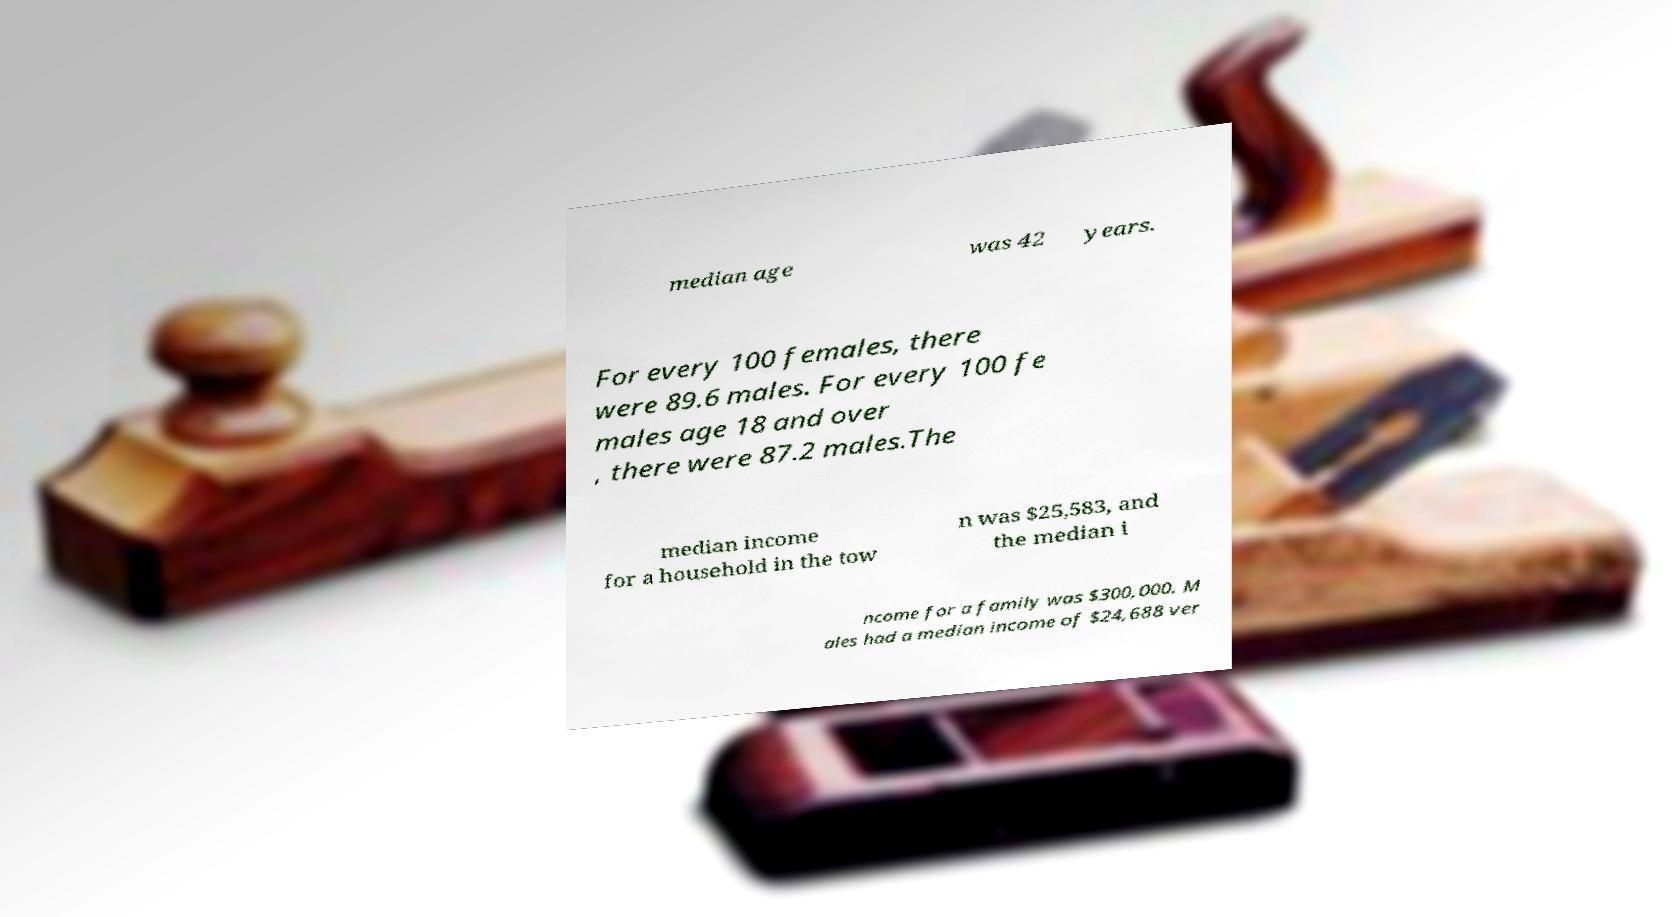Could you extract and type out the text from this image? median age was 42 years. For every 100 females, there were 89.6 males. For every 100 fe males age 18 and over , there were 87.2 males.The median income for a household in the tow n was $25,583, and the median i ncome for a family was $300,000. M ales had a median income of $24,688 ver 